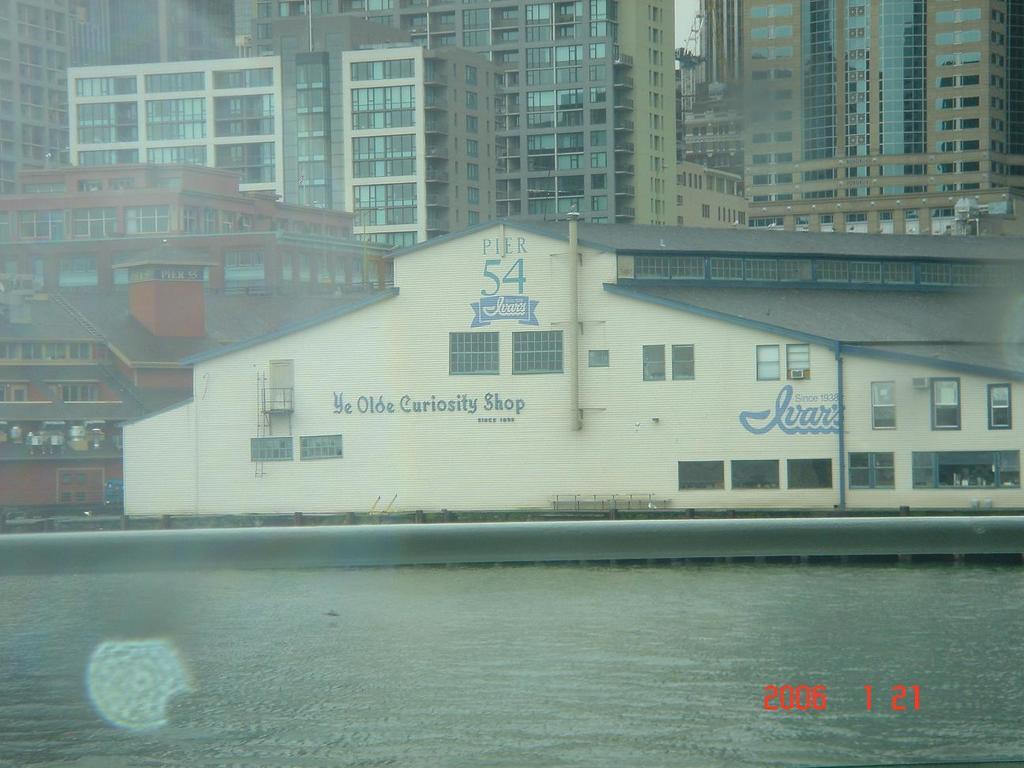What is visible in the image? There is water and a building visible in the image. What can be seen on the building? There is text on the building. What else is present in the background of the image? There are other buildings in the background of the image. What is the condition of the territory surrounding the building in the image? There is no mention of a territory in the image, as it only features water and buildings. What type of work is being done on the building in the image? There is no indication of any work being done on the building in the image, as it only shows the text on the building's facade. 